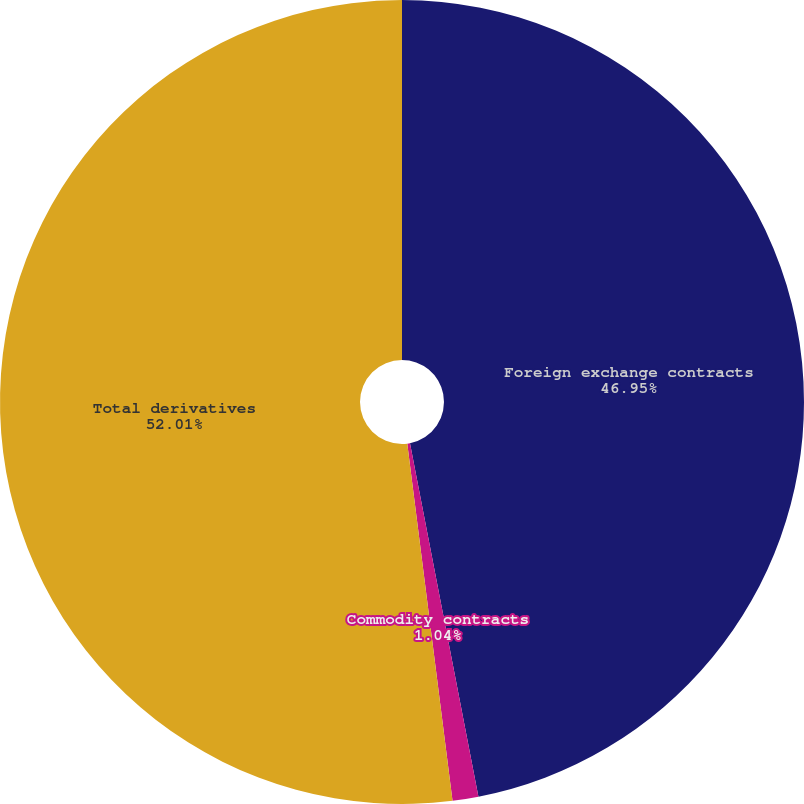<chart> <loc_0><loc_0><loc_500><loc_500><pie_chart><fcel>Foreign exchange contracts<fcel>Commodity contracts<fcel>Total derivatives<nl><fcel>46.95%<fcel>1.04%<fcel>52.0%<nl></chart> 